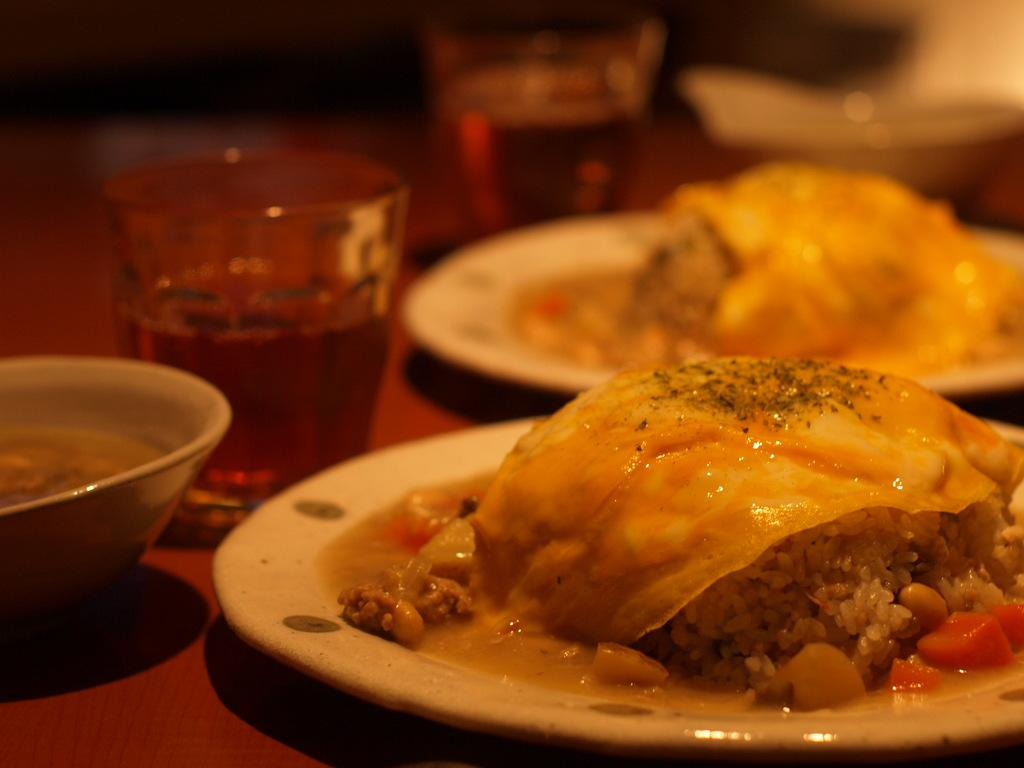How many plates are visible in the image? There are two plates in the image. What else can be seen on the table besides the plates? There are two glasses of drinks and a bowl visible in the image. What is on the plates? There is food on the plates. Can you describe the background of the image? The background of the image is blurry. How many cakes are on the tent in the image? There is no tent or cakes present in the image. 